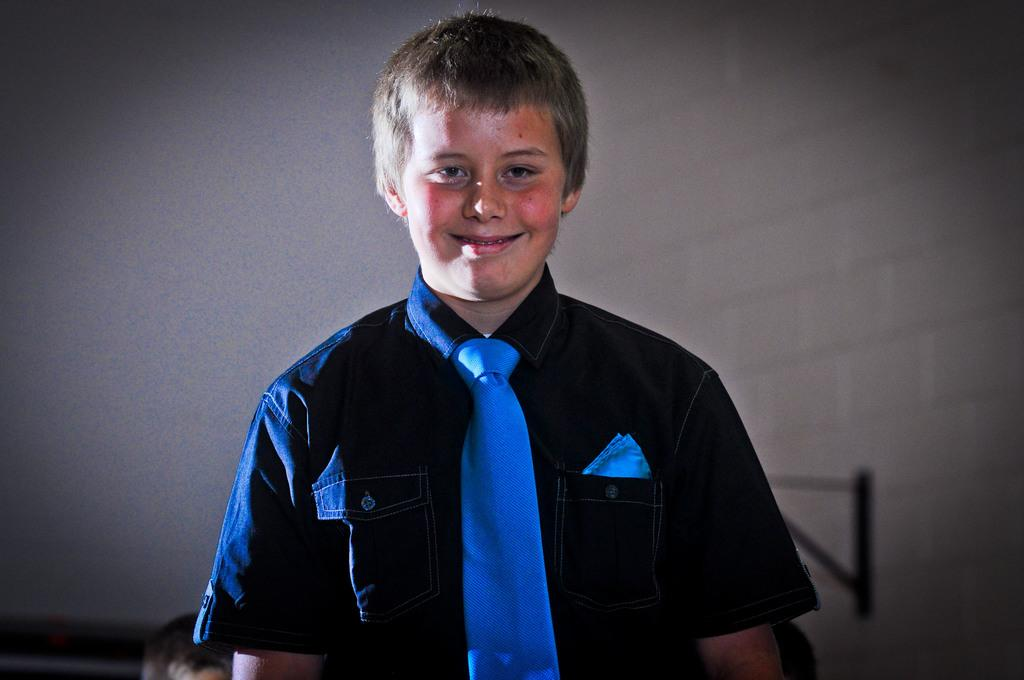Who is the main subject in the picture? There is a boy in the picture. What is the boy wearing? The boy is wearing a blue shirt and tie. What is the boy's facial expression in the picture? The boy is smiling. What is the boy doing in the picture? The boy is posing for the photo. How would you describe the background in the picture? The background behind the boy is blurry. How many girls are lifting a pan in the image? There are no girls or pans present in the image; it features a boy posing for a photo. 